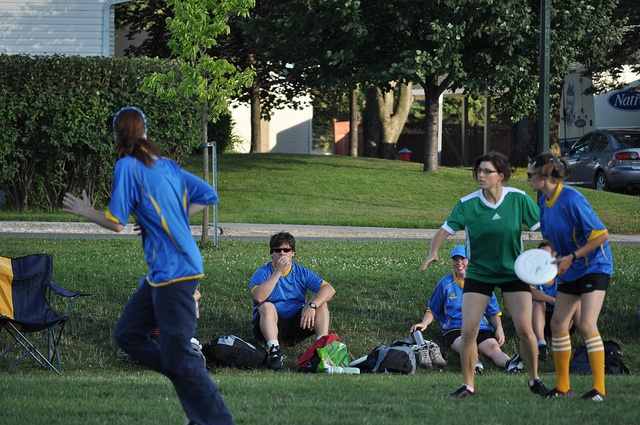Describe the objects in this image and their specific colors. I can see people in darkgray, black, blue, and navy tones, people in darkgray, black, teal, and gray tones, people in darkgray, black, gray, navy, and olive tones, people in darkgray, black, gray, blue, and tan tones, and chair in darkgray, black, navy, darkgreen, and gray tones in this image. 